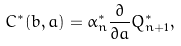<formula> <loc_0><loc_0><loc_500><loc_500>C ^ { * } ( b , a ) = \alpha ^ { * } _ { n } \frac { \partial } { \partial a } Q ^ { * } _ { n + 1 } ,</formula> 